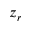Convert formula to latex. <formula><loc_0><loc_0><loc_500><loc_500>z _ { r }</formula> 